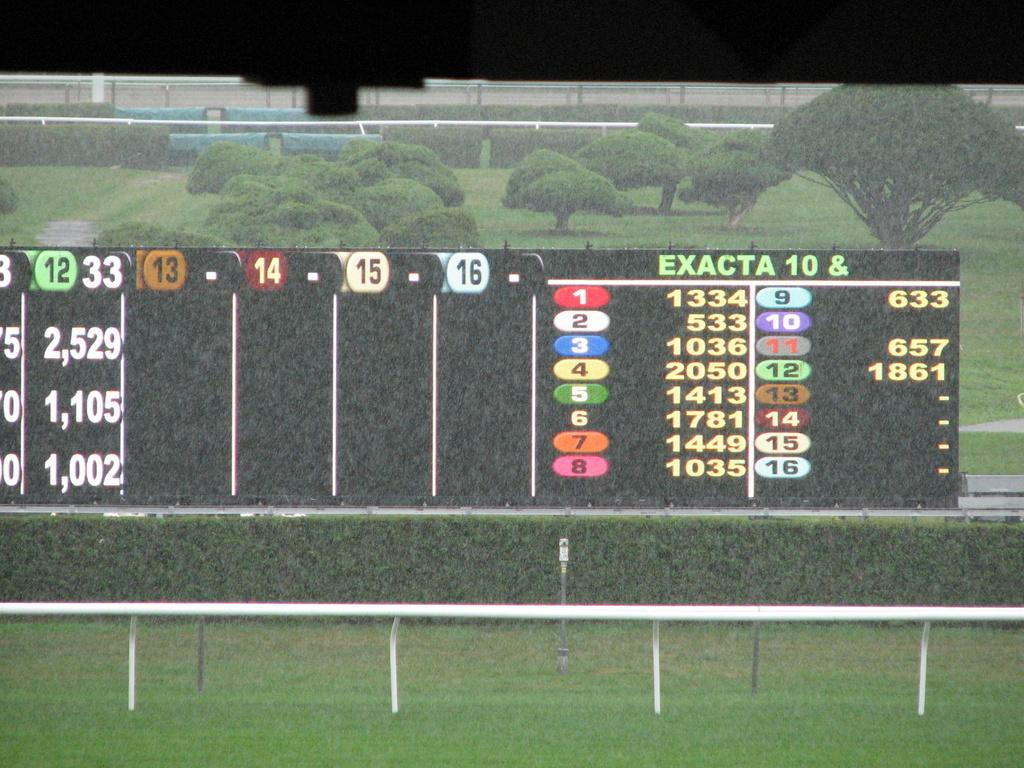<image>
Give a short and clear explanation of the subsequent image. A scoreboard has a column labeled Exacta 10. 